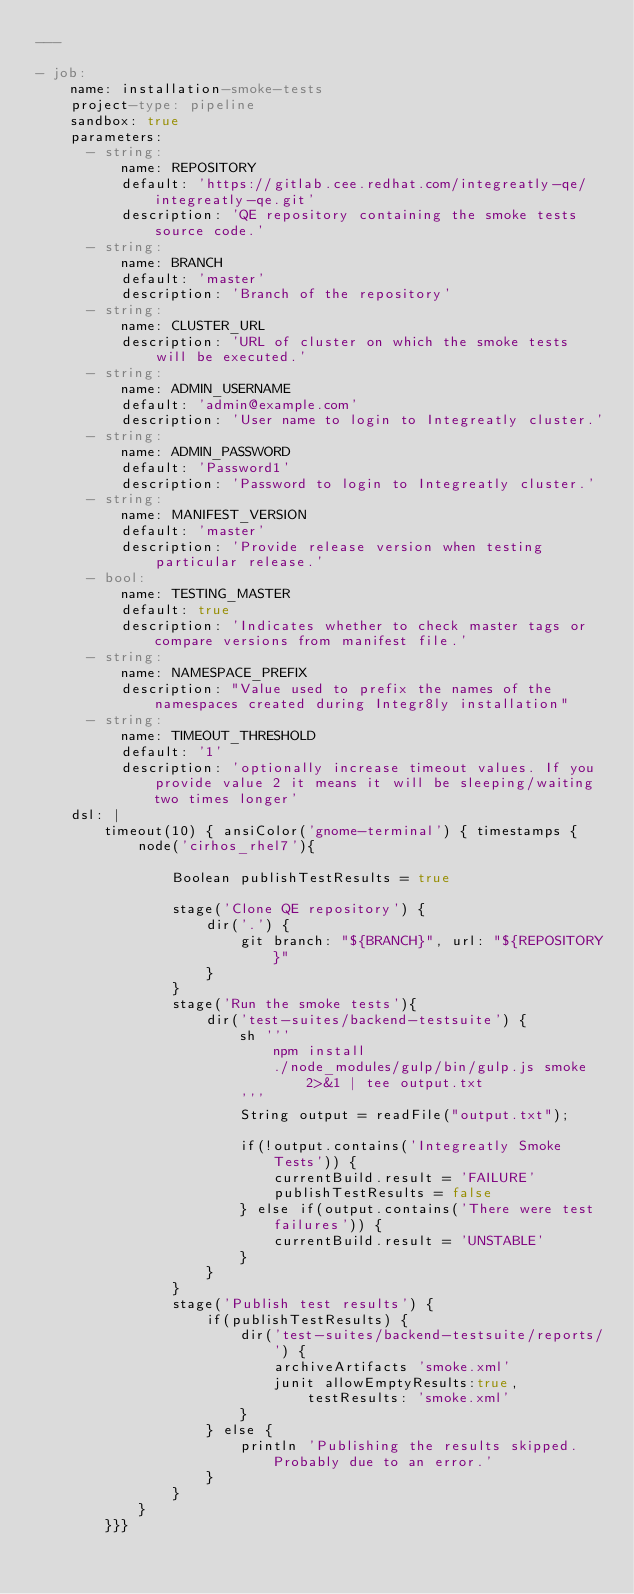<code> <loc_0><loc_0><loc_500><loc_500><_YAML_>---

- job:
    name: installation-smoke-tests
    project-type: pipeline
    sandbox: true
    parameters:
      - string:
          name: REPOSITORY
          default: 'https://gitlab.cee.redhat.com/integreatly-qe/integreatly-qe.git'
          description: 'QE repository containing the smoke tests source code.'
      - string:
          name: BRANCH
          default: 'master'
          description: 'Branch of the repository'
      - string:
          name: CLUSTER_URL
          description: 'URL of cluster on which the smoke tests will be executed.'
      - string: 
          name: ADMIN_USERNAME
          default: 'admin@example.com'
          description: 'User name to login to Integreatly cluster.'
      - string: 
          name: ADMIN_PASSWORD
          default: 'Password1'
          description: 'Password to login to Integreatly cluster.'
      - string:
          name: MANIFEST_VERSION
          default: 'master'
          description: 'Provide release version when testing particular release.'
      - bool:
          name: TESTING_MASTER
          default: true
          description: 'Indicates whether to check master tags or compare versions from manifest file.'
      - string:
          name: NAMESPACE_PREFIX
          description: "Value used to prefix the names of the namespaces created during Integr8ly installation"
      - string:
          name: TIMEOUT_THRESHOLD
          default: '1'
          description: 'optionally increase timeout values. If you provide value 2 it means it will be sleeping/waiting two times longer'      
    dsl: |
        timeout(10) { ansiColor('gnome-terminal') { timestamps {
            node('cirhos_rhel7'){

                Boolean publishTestResults = true

                stage('Clone QE repository') {
                    dir('.') {
                        git branch: "${BRANCH}", url: "${REPOSITORY}"
                    }
                }
                stage('Run the smoke tests'){
                    dir('test-suites/backend-testsuite') {
                        sh '''
                            npm install
                            ./node_modules/gulp/bin/gulp.js smoke 2>&1 | tee output.txt
                        '''  
                        String output = readFile("output.txt");
                        
                        if(!output.contains('Integreatly Smoke Tests')) {
                            currentBuild.result = 'FAILURE'
                            publishTestResults = false
                        } else if(output.contains('There were test failures')) {
                            currentBuild.result = 'UNSTABLE'
                        }
                    }
                }
                stage('Publish test results') {
                    if(publishTestResults) {
                        dir('test-suites/backend-testsuite/reports/') {
                            archiveArtifacts 'smoke.xml'                  
                            junit allowEmptyResults:true, testResults: 'smoke.xml'
                        }
                    } else {
                        println 'Publishing the results skipped. Probably due to an error.'
                    }
                }
            }
        }}}
</code> 